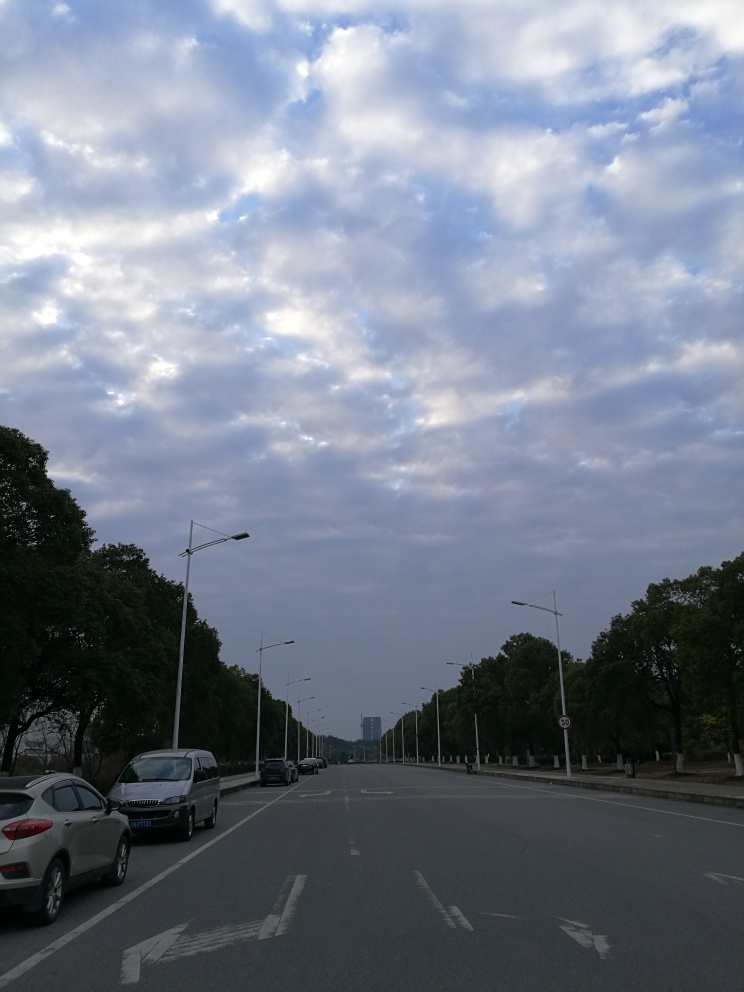What is the graininess in the photo? Upon inspection, the photo exhibits a very low level of graininess, which is indicative of a smooth texture in the visual details. Therefore, the accurate choice would be option 'D. Low.' When assessing graininess in an image, we look for visual noise and the clarity of the fine details, which in this case, seem to be quite clear. 